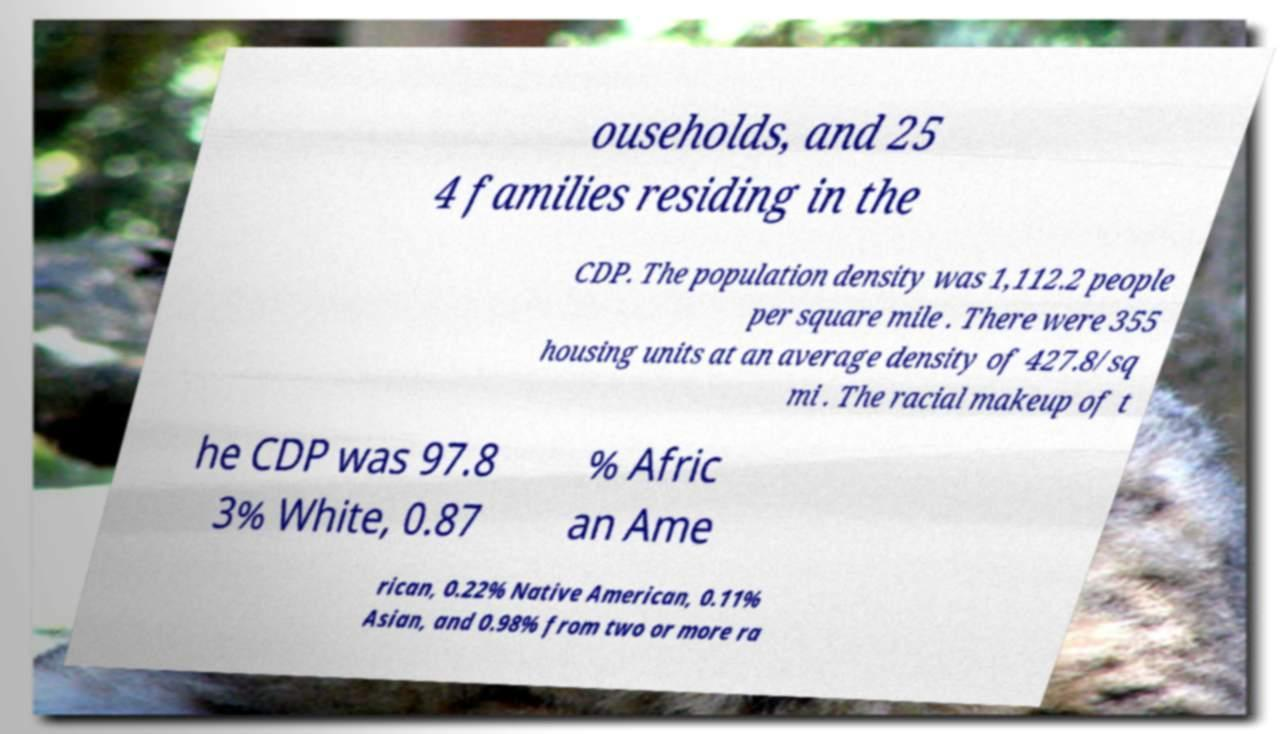Could you extract and type out the text from this image? ouseholds, and 25 4 families residing in the CDP. The population density was 1,112.2 people per square mile . There were 355 housing units at an average density of 427.8/sq mi . The racial makeup of t he CDP was 97.8 3% White, 0.87 % Afric an Ame rican, 0.22% Native American, 0.11% Asian, and 0.98% from two or more ra 